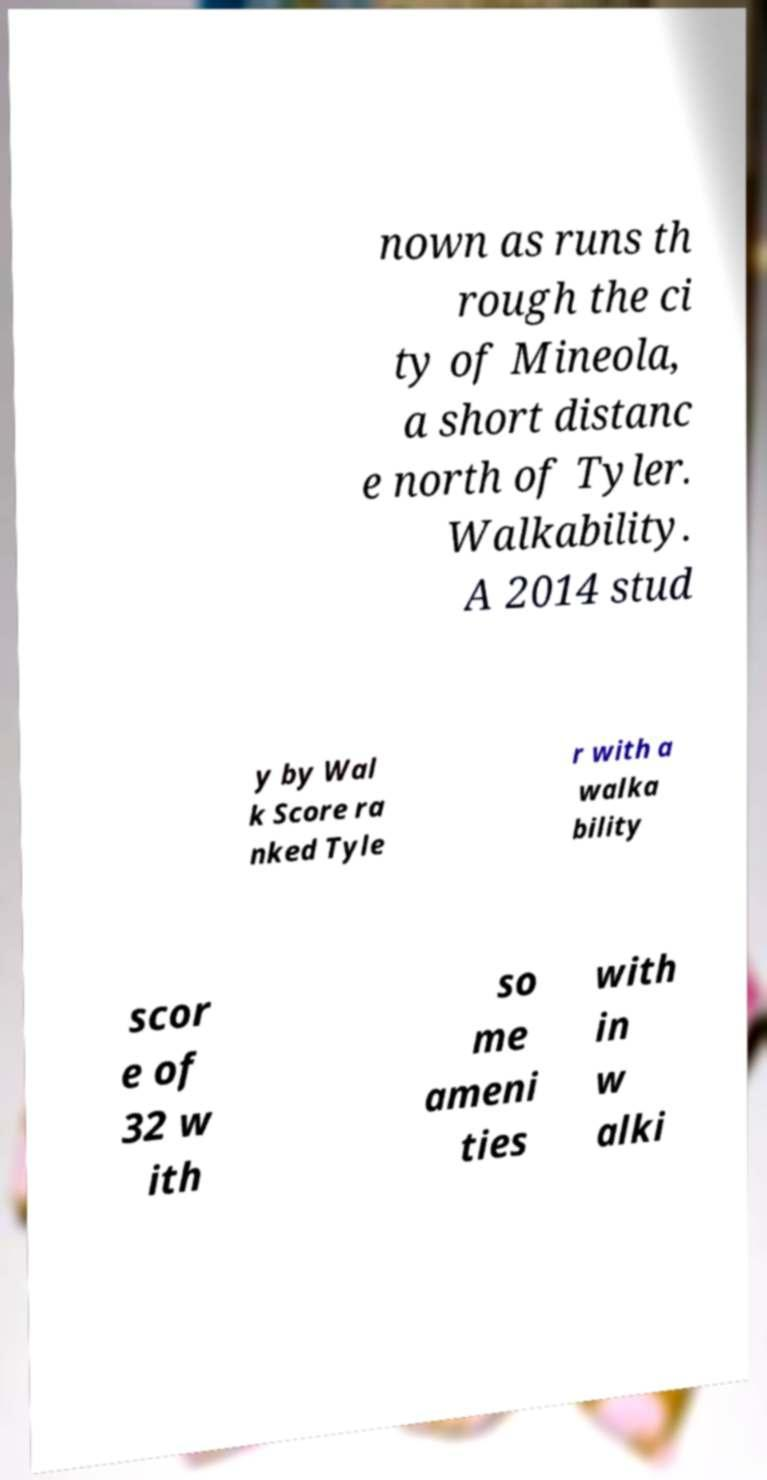I need the written content from this picture converted into text. Can you do that? nown as runs th rough the ci ty of Mineola, a short distanc e north of Tyler. Walkability. A 2014 stud y by Wal k Score ra nked Tyle r with a walka bility scor e of 32 w ith so me ameni ties with in w alki 